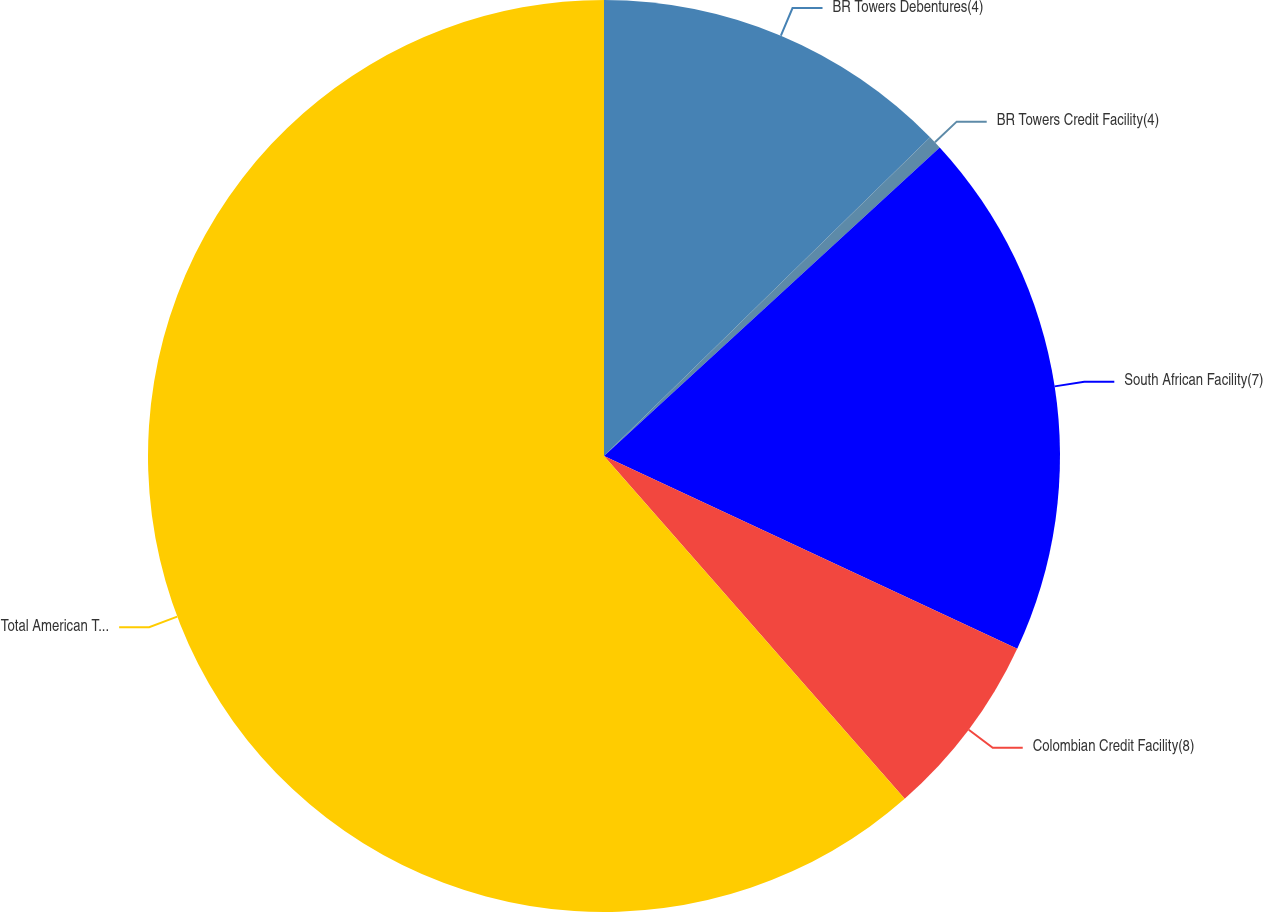<chart> <loc_0><loc_0><loc_500><loc_500><pie_chart><fcel>BR Towers Debentures(4)<fcel>BR Towers Credit Facility(4)<fcel>South African Facility(7)<fcel>Colombian Credit Facility(8)<fcel>Total American Tower<nl><fcel>12.68%<fcel>0.49%<fcel>18.78%<fcel>6.59%<fcel>61.46%<nl></chart> 